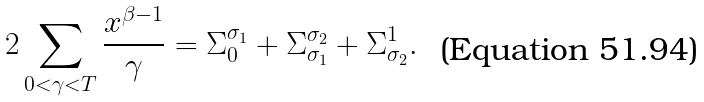<formula> <loc_0><loc_0><loc_500><loc_500>2 \sum _ { 0 < \gamma < T } \frac { x ^ { \beta - 1 } } { \gamma } = \Sigma _ { 0 } ^ { \sigma _ { 1 } } + \Sigma _ { \sigma _ { 1 } } ^ { \sigma _ { 2 } } + \Sigma _ { \sigma _ { 2 } } ^ { 1 } .</formula> 